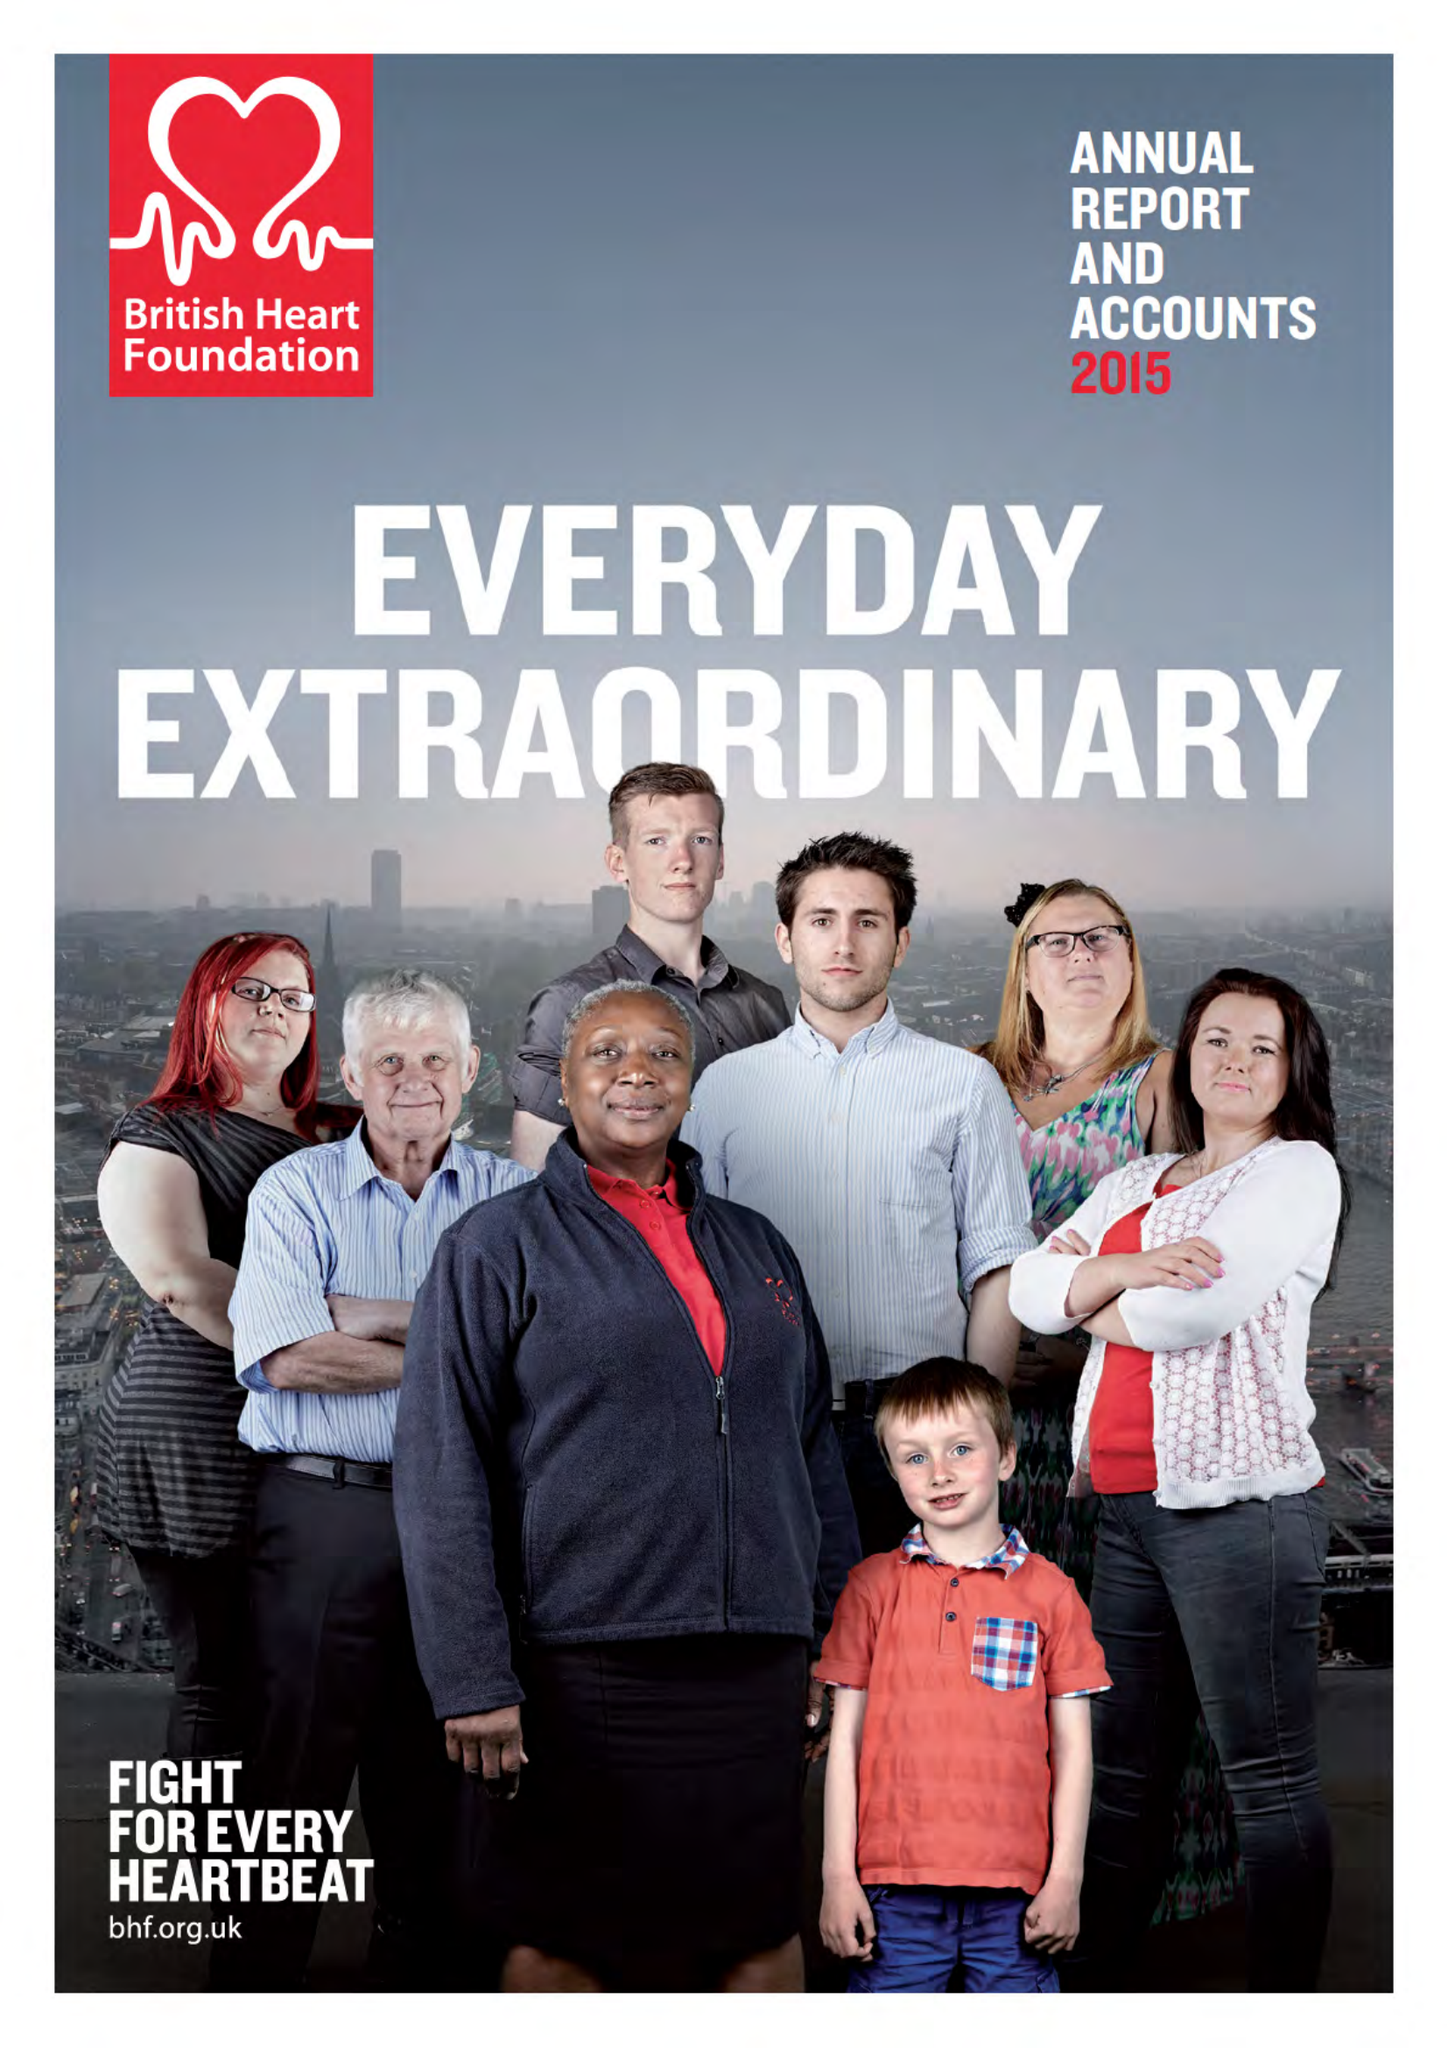What is the value for the address__post_town?
Answer the question using a single word or phrase. LONDON 